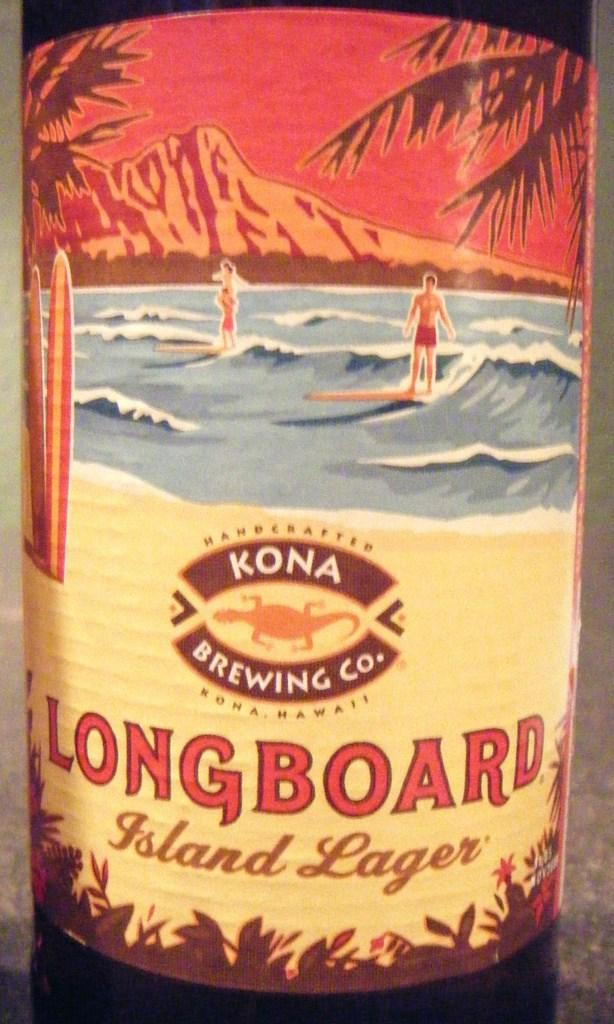<image>
Give a short and clear explanation of the subsequent image. a bottle that has a label on it that says 'longboard island lager' 